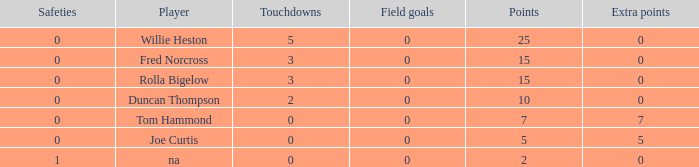How many Touchdowns have a Player of rolla bigelow, and an Extra points smaller than 0? None. 